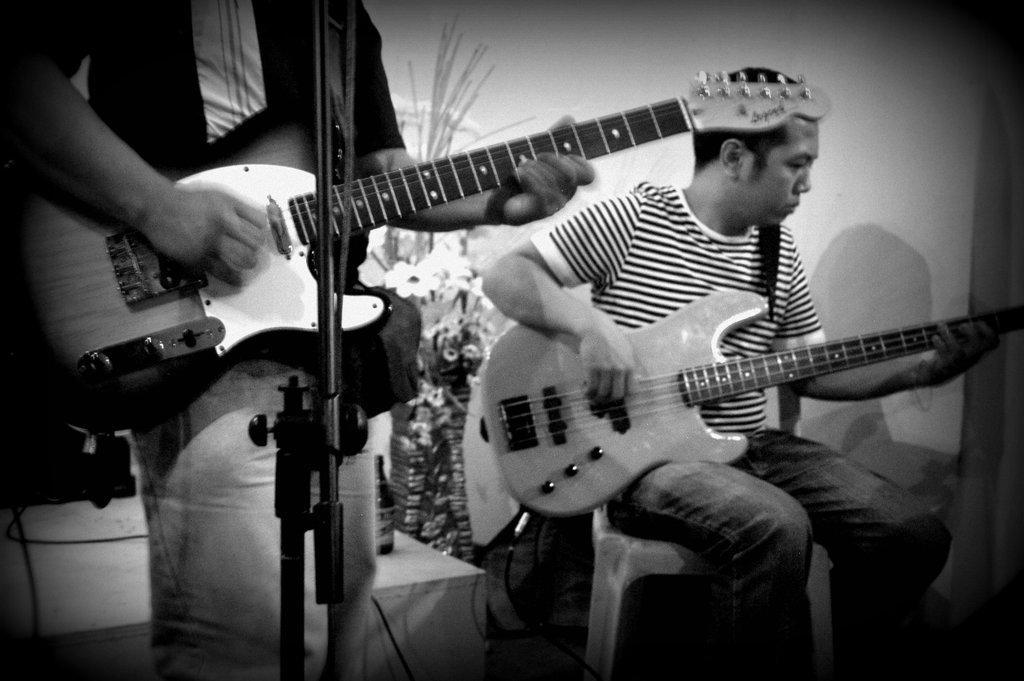Can you describe this image briefly? In this picture two persons are holding a guitar and to the left side a person is having a mic in front of him and right side person is sitting on the chair in the back ground i could see a flowers and a flower pot and in the middle there is a table, on the table there is a bottle. This is a black and white picture. 